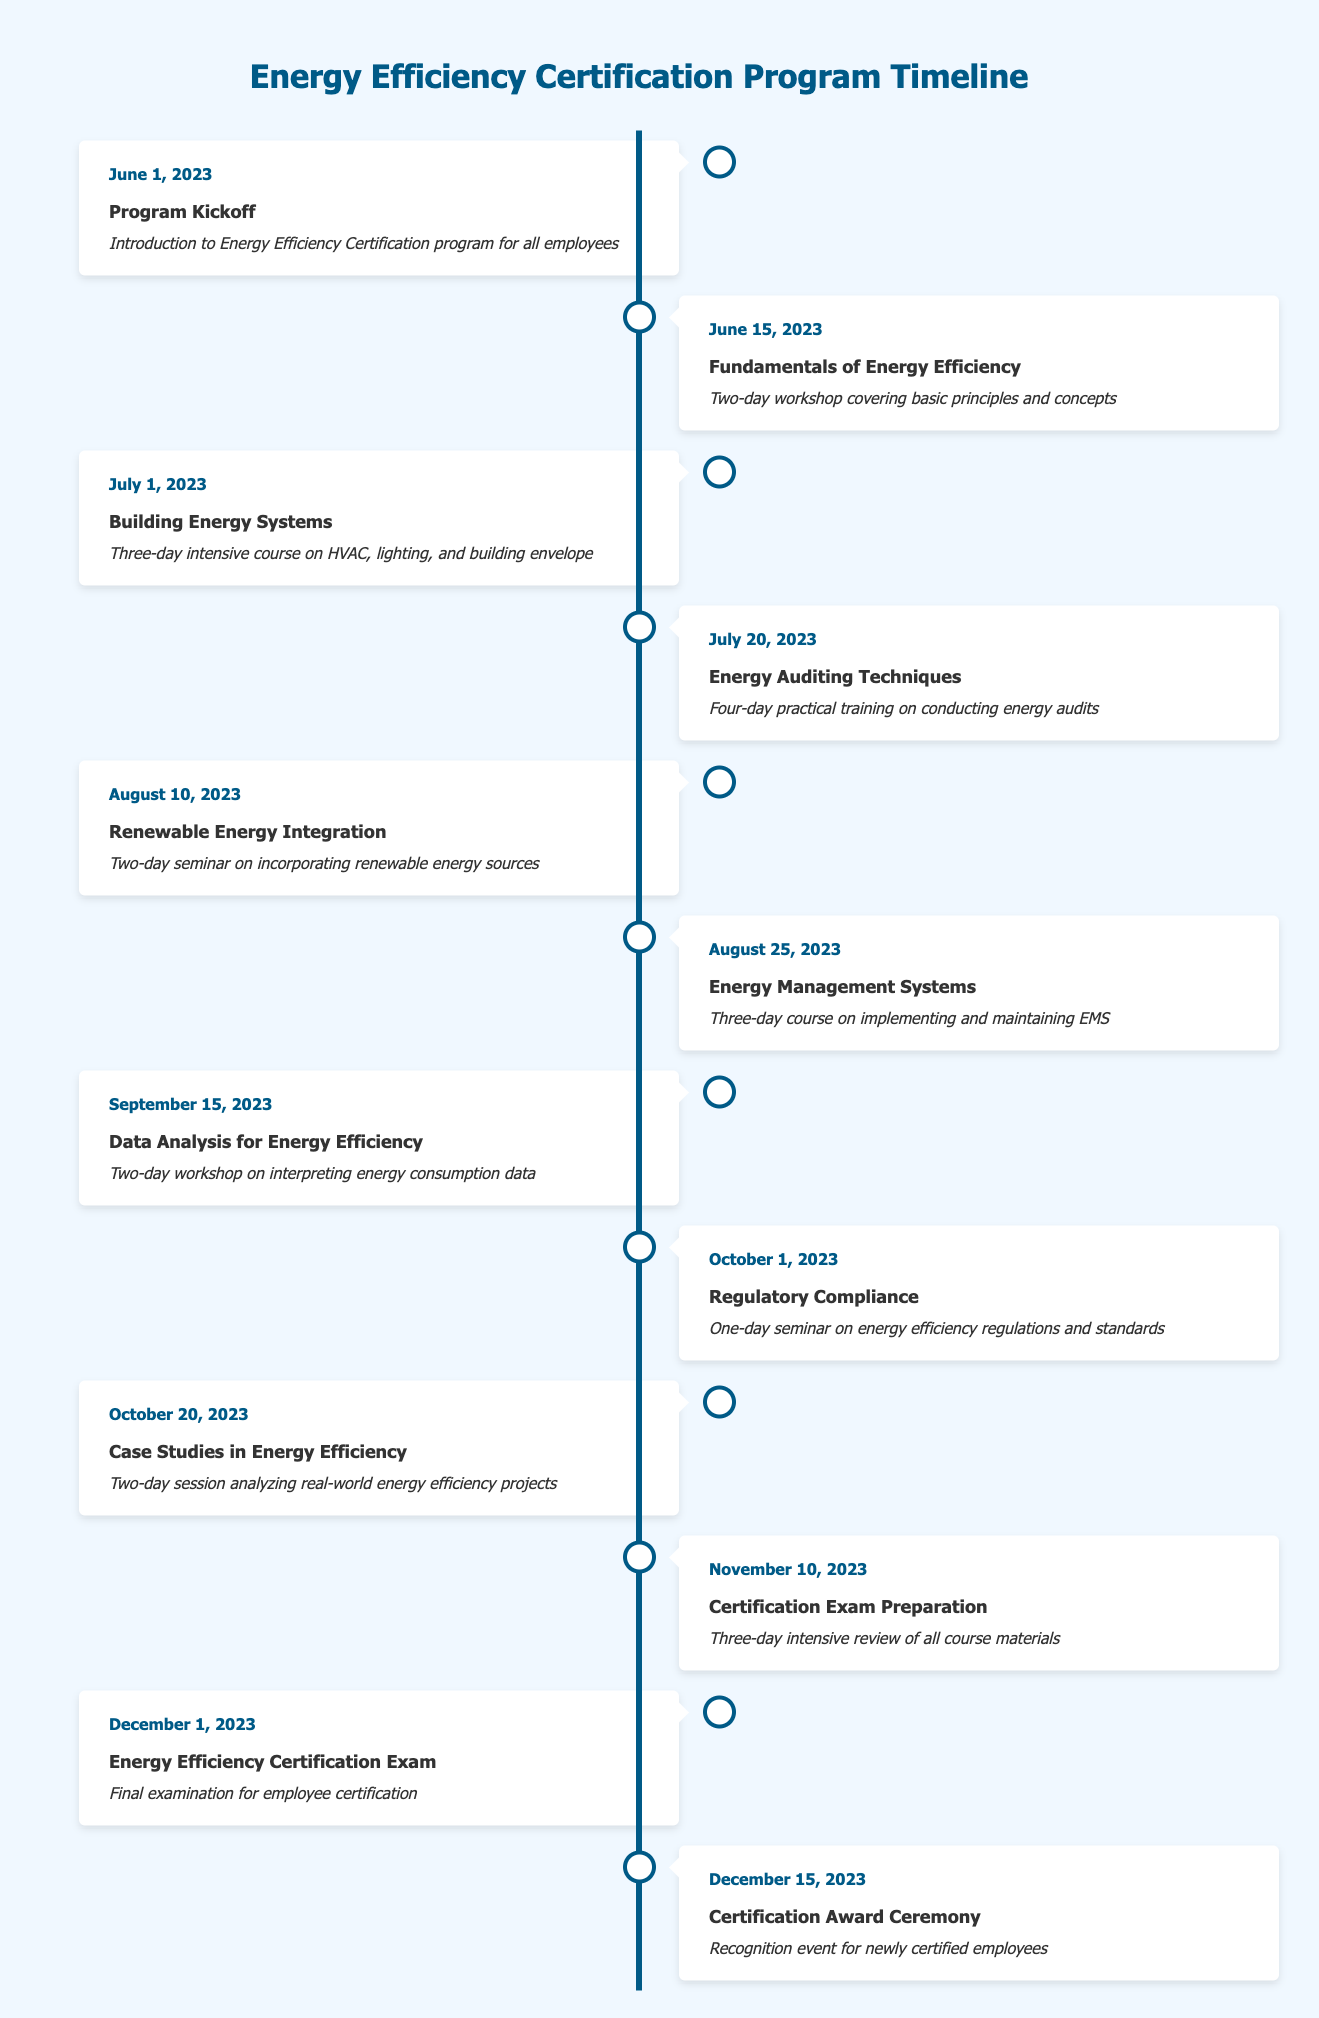What is the date of the Program Kickoff event? The Program Kickoff event is listed first in the timeline, with its date specified as June 1, 2023.
Answer: June 1, 2023 How many days long is the Energy Auditing Techniques training? The Energy Auditing Techniques event states that it is a four-day practical training on conducting energy audits, which can be directly seen from the description.
Answer: Four days What event is taking place immediately after the Renewable Energy Integration seminar? The Renewable Energy Integration seminar occurs on August 10, 2023, and the next event listed is the Energy Management Systems course on August 25, 2023. Therefore, Energy Management Systems follows immediately after the seminar.
Answer: Energy Management Systems Is the Energy Efficiency Certification Exam scheduled before the Certification Exam Preparation? The Energy Efficiency Certification Exam is scheduled for December 1, 2023, while the Certification Exam Preparation is on November 10, 2023, which means the exam is scheduled after the preparation event.
Answer: No What is the total duration of the workshops conducted in September? The Data Analysis for Energy Efficiency workshop in September is a two-day event. Since it is the only September event listed, the total duration is simply two days.
Answer: Two days When is the Certification Award Ceremony scheduled in relation to the Certification Exam? The Certification Award Ceremony is scheduled for December 15, 2023, which occurs two weeks after the Energy Efficiency Certification Exam, which is on December 1, 2023.
Answer: Two weeks later How many events in total are scheduled for the months of June and July combined? From the timeline, June has 2 events (Program Kickoff and Fundamentals of Energy Efficiency), and July has 2 events (Building Energy Systems and Energy Auditing Techniques), adding these gives a total of 4 events in June and July.
Answer: Four events Which event in the timeline has the shortest duration? When comparing the durations, the shortest is the Regulatory Compliance seminar, which is a one-day seminar scheduled for October 1, 2023. This is clearly stated in its description.
Answer: One day What are the names of the two events occurring in October? The two events listed for October are Regulatory Compliance on October 1, 2023, and Case Studies in Energy Efficiency on October 20, 2023. Both names can be found in their respective rows.
Answer: Regulatory Compliance, Case Studies in Energy Efficiency 